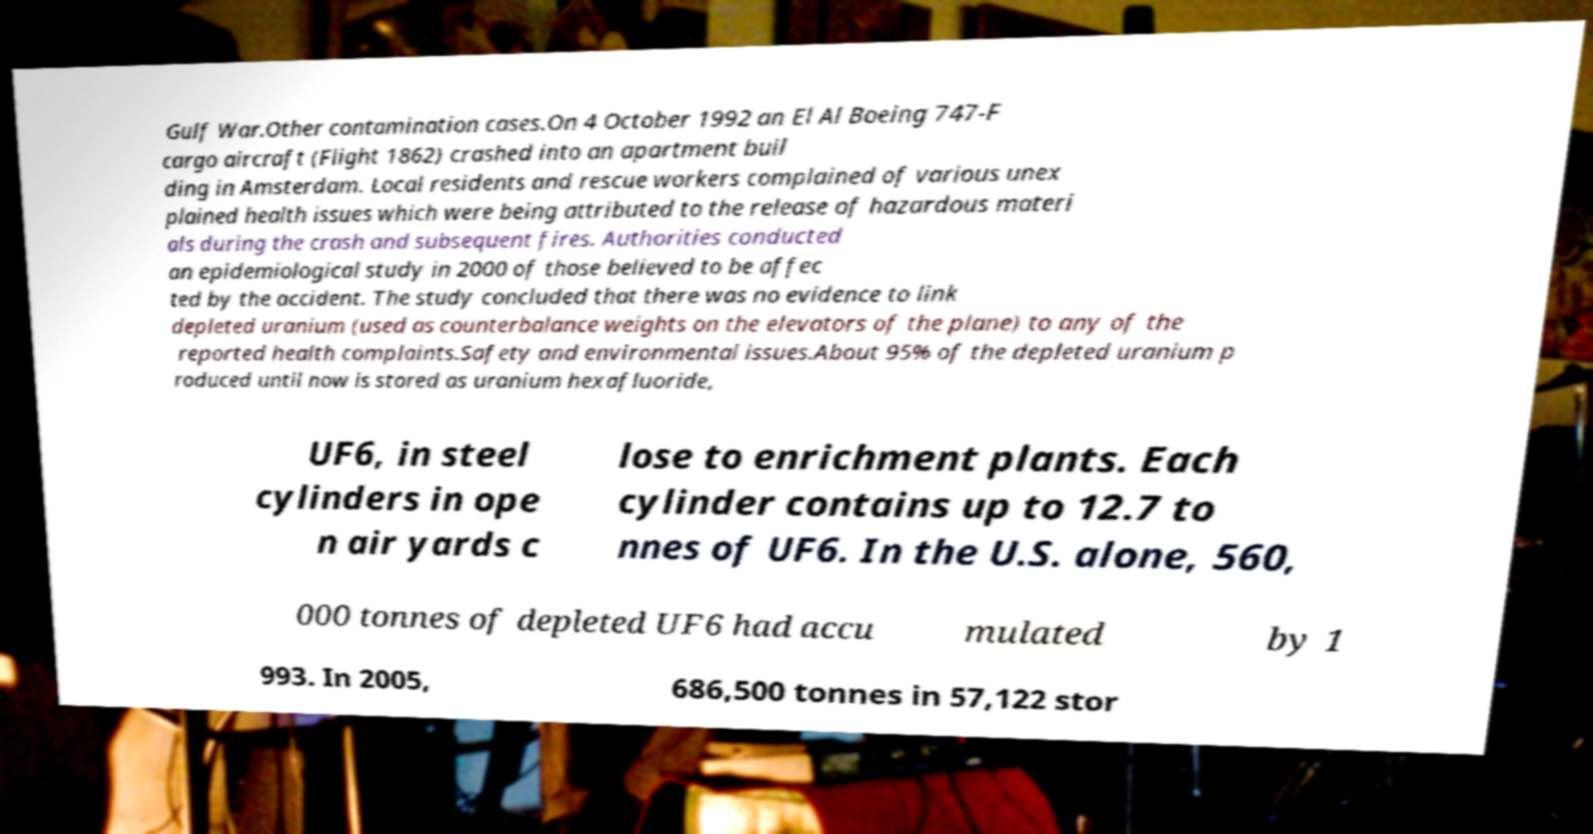I need the written content from this picture converted into text. Can you do that? Gulf War.Other contamination cases.On 4 October 1992 an El Al Boeing 747-F cargo aircraft (Flight 1862) crashed into an apartment buil ding in Amsterdam. Local residents and rescue workers complained of various unex plained health issues which were being attributed to the release of hazardous materi als during the crash and subsequent fires. Authorities conducted an epidemiological study in 2000 of those believed to be affec ted by the accident. The study concluded that there was no evidence to link depleted uranium (used as counterbalance weights on the elevators of the plane) to any of the reported health complaints.Safety and environmental issues.About 95% of the depleted uranium p roduced until now is stored as uranium hexafluoride, UF6, in steel cylinders in ope n air yards c lose to enrichment plants. Each cylinder contains up to 12.7 to nnes of UF6. In the U.S. alone, 560, 000 tonnes of depleted UF6 had accu mulated by 1 993. In 2005, 686,500 tonnes in 57,122 stor 